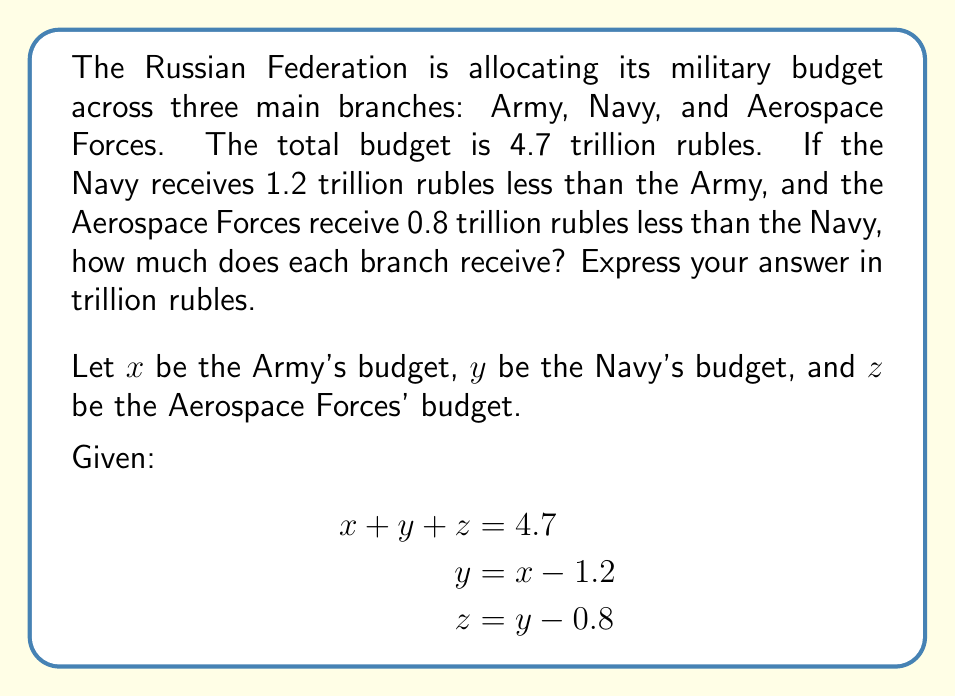Provide a solution to this math problem. To solve this system of equations, we'll use substitution:

1) From the second equation, we know that $y = x - 1.2$
2) From the third equation, we can substitute for $y$:
   $z = (x - 1.2) - 0.8 = x - 2$

3) Now we can substitute these into the first equation:
   $$x + (x - 1.2) + (x - 2) = 4.7$$

4) Simplify:
   $$x + x - 1.2 + x - 2 = 4.7$$
   $$3x - 3.2 = 4.7$$

5) Add 3.2 to both sides:
   $$3x = 7.9$$

6) Divide by 3:
   $$x = \frac{7.9}{3} \approx 2.63333$$

7) Now we can find $y$ and $z$:
   $y = x - 1.2 = 2.63333 - 1.2 = 1.43333$
   $z = y - 0.8 = 1.43333 - 0.8 = 0.63333$

8) Verify the total:
   $2.63333 + 1.43333 + 0.63333 = 4.7$
Answer: Army: 2.63 trillion rubles
Navy: 1.43 trillion rubles
Aerospace Forces: 0.63 trillion rubles 